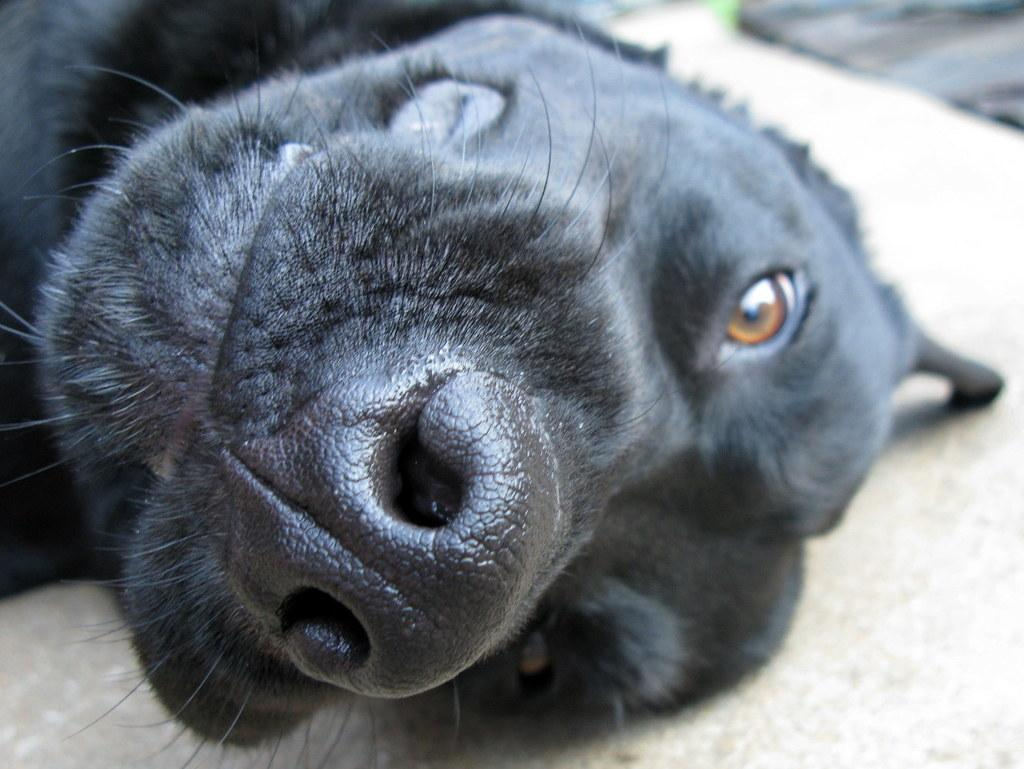What type of animal is in the image? There is a black dog in the image. Where is the dog located in the image? The dog is on a surface. Can you describe the background of the image? The background of the image is blurry. What type of boundary can be seen in the image? There is no boundary visible in the image; it only features a black dog on a surface with a blurry background. 